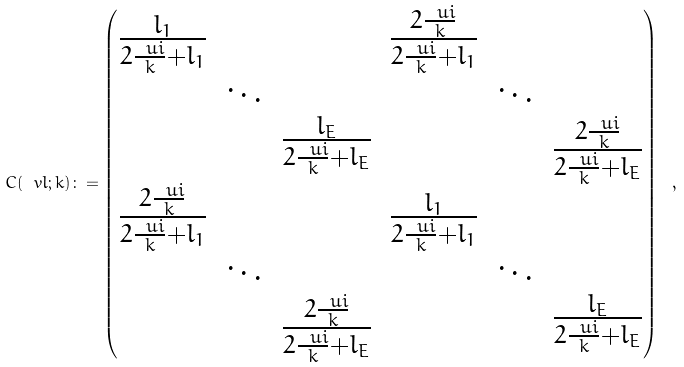Convert formula to latex. <formula><loc_0><loc_0><loc_500><loc_500>C ( \ v l ; k ) \colon = \begin{pmatrix} \begin{matrix} \frac { l _ { 1 } } { 2 \frac { \ u i } { k } + l _ { 1 } } & & \\ & \ddots & \\ & & \frac { l _ { E } } { 2 \frac { \ u i } { k } + l _ { E } } \end{matrix} & \begin{matrix} \frac { 2 \frac { \ u i } { k } } { 2 \frac { \ u i } { k } + l _ { 1 } } & & \\ & \ddots & \\ & & \frac { 2 \frac { \ u i } { k } } { 2 \frac { \ u i } { k } + l _ { E } } \end{matrix} \\ \begin{matrix} \frac { 2 \frac { \ u i } { k } } { 2 \frac { \ u i } { k } + l _ { 1 } } & & \\ & \ddots & \\ & & \frac { 2 \frac { \ u i } { k } } { 2 \frac { \ u i } { k } + l _ { E } } \end{matrix} & \begin{matrix} \frac { l _ { 1 } } { 2 \frac { \ u i } { k } + l _ { 1 } } & & \\ & \ddots & \\ & & \frac { l _ { E } } { 2 \frac { \ u i } { k } + l _ { E } } \end{matrix} \end{pmatrix} \ ,</formula> 